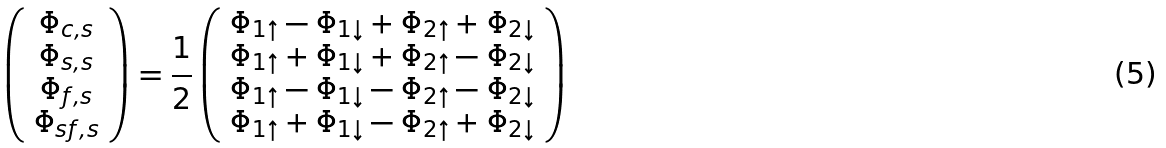Convert formula to latex. <formula><loc_0><loc_0><loc_500><loc_500>\left ( \begin{array} { c } \Phi _ { c , s } \\ \Phi _ { s , s } \\ \Phi _ { f , s } \\ \Phi _ { s f , s } \end{array} \right ) = \frac { 1 } { 2 } \left ( \begin{array} { c } \Phi _ { 1 \uparrow } - \Phi _ { 1 \downarrow } + \Phi _ { 2 \uparrow } + \Phi _ { 2 \downarrow } \\ \Phi _ { 1 \uparrow } + \Phi _ { 1 \downarrow } + \Phi _ { 2 \uparrow } - \Phi _ { 2 \downarrow } \\ \Phi _ { 1 \uparrow } - \Phi _ { 1 \downarrow } - \Phi _ { 2 \uparrow } - \Phi _ { 2 \downarrow } \\ \Phi _ { 1 \uparrow } + \Phi _ { 1 \downarrow } - \Phi _ { 2 \uparrow } + \Phi _ { 2 \downarrow } \end{array} \right )</formula> 